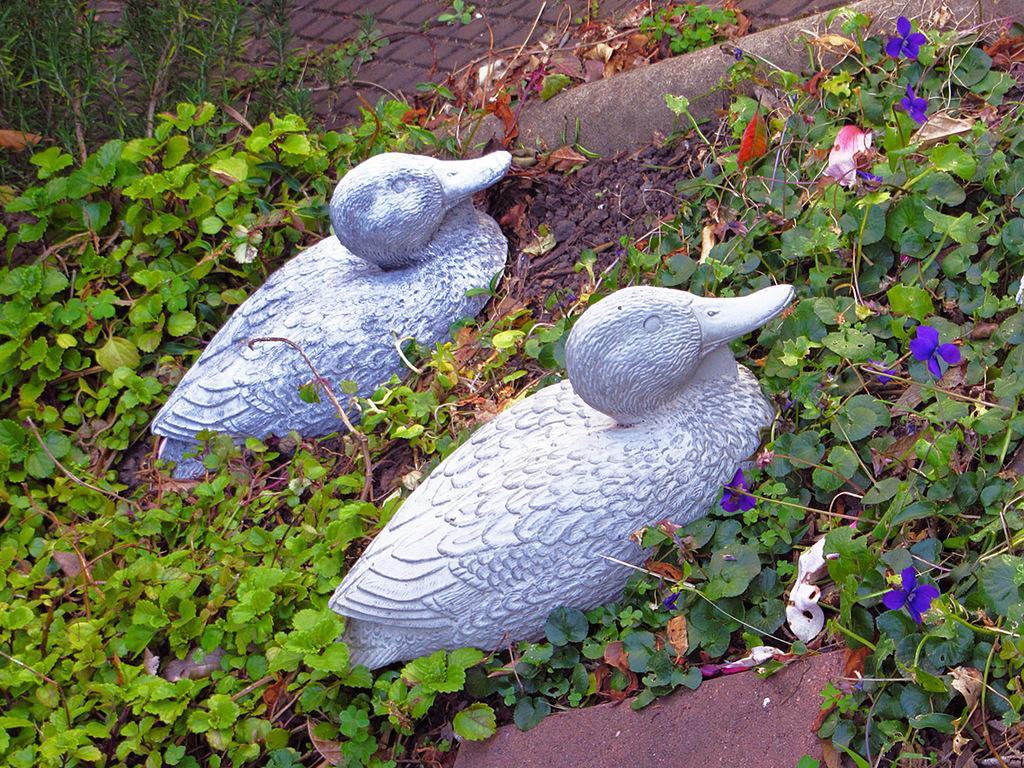Can you describe this image briefly? In this image we can see two sculptures on the ground. In the background, we can see some plants. 